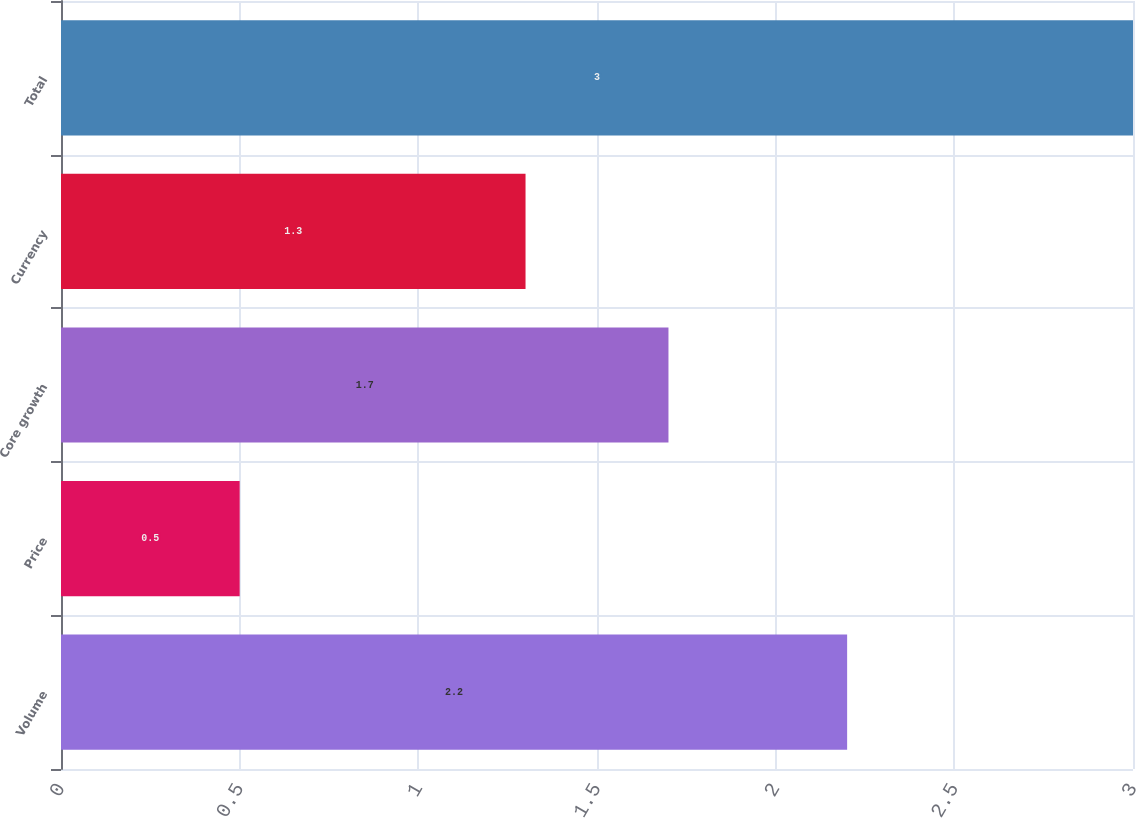Convert chart to OTSL. <chart><loc_0><loc_0><loc_500><loc_500><bar_chart><fcel>Volume<fcel>Price<fcel>Core growth<fcel>Currency<fcel>Total<nl><fcel>2.2<fcel>0.5<fcel>1.7<fcel>1.3<fcel>3<nl></chart> 